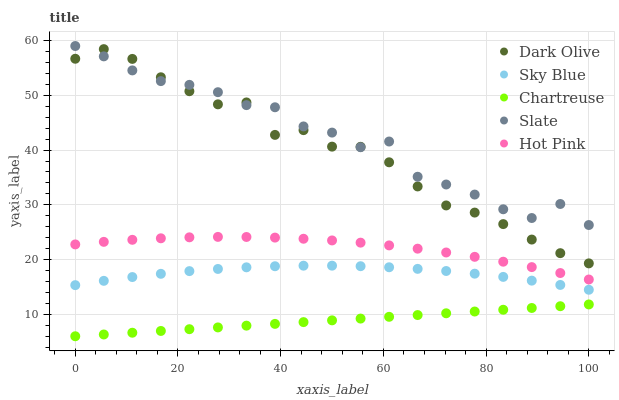Does Chartreuse have the minimum area under the curve?
Answer yes or no. Yes. Does Slate have the maximum area under the curve?
Answer yes or no. Yes. Does Dark Olive have the minimum area under the curve?
Answer yes or no. No. Does Dark Olive have the maximum area under the curve?
Answer yes or no. No. Is Chartreuse the smoothest?
Answer yes or no. Yes. Is Slate the roughest?
Answer yes or no. Yes. Is Dark Olive the smoothest?
Answer yes or no. No. Is Dark Olive the roughest?
Answer yes or no. No. Does Chartreuse have the lowest value?
Answer yes or no. Yes. Does Dark Olive have the lowest value?
Answer yes or no. No. Does Slate have the highest value?
Answer yes or no. Yes. Does Dark Olive have the highest value?
Answer yes or no. No. Is Hot Pink less than Dark Olive?
Answer yes or no. Yes. Is Hot Pink greater than Chartreuse?
Answer yes or no. Yes. Does Dark Olive intersect Slate?
Answer yes or no. Yes. Is Dark Olive less than Slate?
Answer yes or no. No. Is Dark Olive greater than Slate?
Answer yes or no. No. Does Hot Pink intersect Dark Olive?
Answer yes or no. No. 